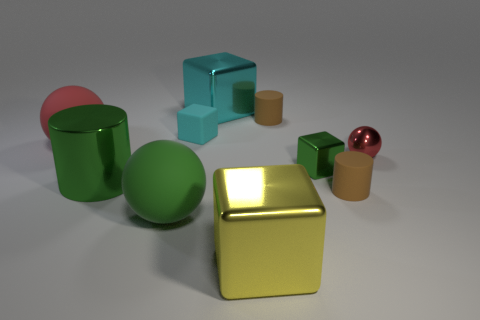There is a yellow thing; how many small brown rubber objects are to the right of it?
Provide a short and direct response. 2. Are there fewer small cyan objects in front of the large green metallic object than brown cylinders?
Ensure brevity in your answer.  Yes. The large cylinder has what color?
Offer a very short reply. Green. Does the tiny block that is left of the small green shiny block have the same color as the tiny shiny cube?
Your response must be concise. No. The other tiny rubber thing that is the same shape as the yellow object is what color?
Provide a short and direct response. Cyan. How many tiny things are red rubber spheres or green spheres?
Your response must be concise. 0. How big is the brown cylinder behind the small green metal cube?
Your response must be concise. Small. Are there any shiny cubes that have the same color as the metal cylinder?
Your response must be concise. Yes. Is the small shiny cube the same color as the small ball?
Give a very brief answer. No. What shape is the matte thing that is the same color as the metallic ball?
Provide a short and direct response. Sphere. 